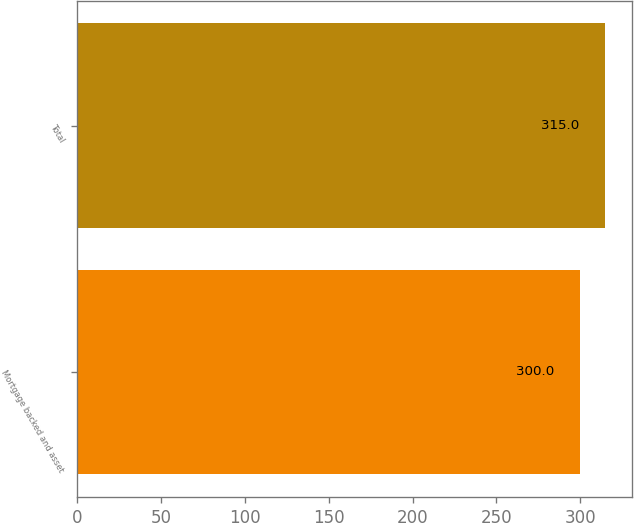<chart> <loc_0><loc_0><loc_500><loc_500><bar_chart><fcel>Mortgage backed and asset<fcel>Total<nl><fcel>300<fcel>315<nl></chart> 